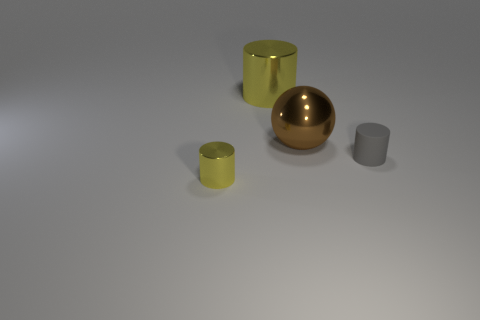Subtract all red cylinders. Subtract all cyan spheres. How many cylinders are left? 3 Add 2 metallic things. How many objects exist? 6 Subtract all balls. How many objects are left? 3 Add 4 balls. How many balls exist? 5 Subtract 0 yellow balls. How many objects are left? 4 Subtract all tiny cyan balls. Subtract all cylinders. How many objects are left? 1 Add 2 small rubber cylinders. How many small rubber cylinders are left? 3 